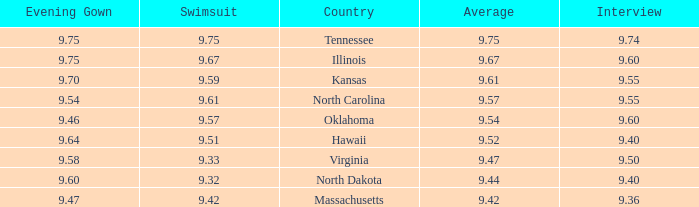61? 9.54. 